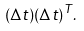<formula> <loc_0><loc_0><loc_500><loc_500>( \Delta t ) ( \Delta t ) ^ { T } .</formula> 